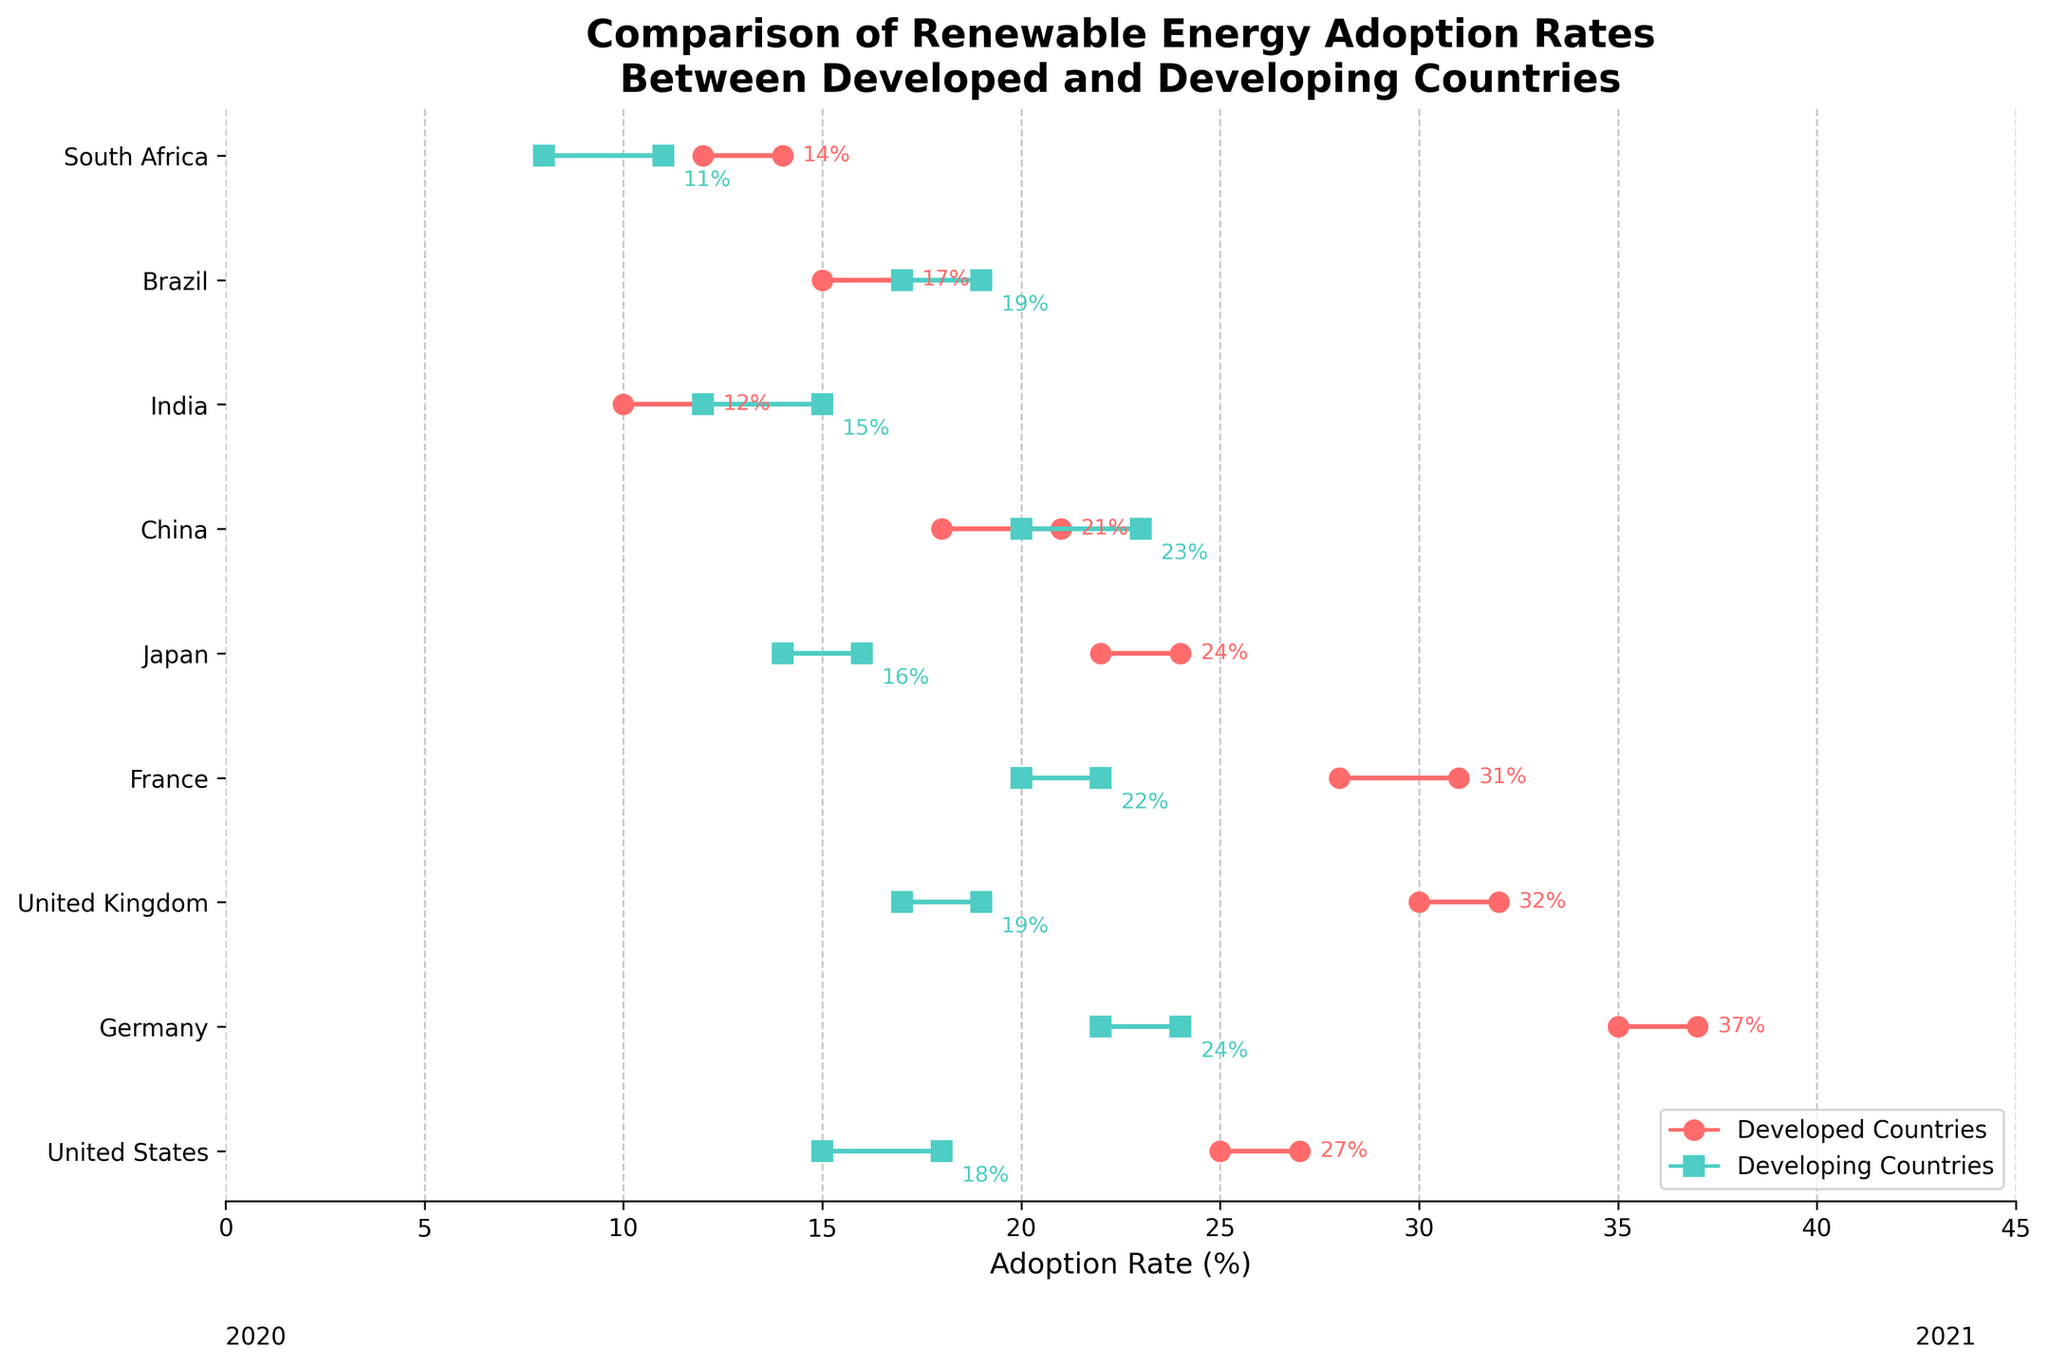What is the adoption rate for developed countries in the United States in 2020? Looking at the United States data points on the plot, the adoption rate for developed countries in 2020 is shown as 25%.
Answer: 25% What is the difference in the adoption rates of developed and developing countries in Germany in 2021? For Germany in 2021, the adoption rates are 37% for developed countries and 24% for developing countries. The difference is 37% - 24% = 13%.
Answer: 13% Which country has the highest adoption rate for developed countries in 2021? Looking at the most rightward point of all red markers (developed countries) in 2021, Germany has the highest value at 37%.
Answer: Germany Which developing country has shown the most significant increase in adoption rate from 2020 to 2021? By comparing the movement of the green markers (developing countries) from 2020 to 2021, China has the most significant increase, going from 20% to 23%, a 3% increase.
Answer: China What is the average adoption rate for developed countries in 2020 across all shown countries? Sum the adoption rates for developed countries in 2020: 25 + 35 + 30 + 28 + 22 + 18 + 10 + 15 + 12 = 195. There are 9 countries, so the average is 195 / 9 ≈ 21.67%.
Answer: 21.67% What is the median adoption rate for developing countries in 2020? List the 2020 developing adoption rates in ascending order: 8, 12, 14, 15, 17, 17, 20, 22. The number of data points is odd (9), so the median is the value in the middle: 17%.
Answer: 17% How does Brazil’s adoption rate for developed countries compare between 2020 and 2021? The adoption rate for Brazil in developed countries increased from 15% in 2020 to 17% in 2021, showing a 2% increase.
Answer: Increased by 2% In 2021, which country has the smallest gap between developed and developing adoption rates? Looking at 2021 data, identify the smallest gap by comparing the differences. Brazil has the smallest gap, with developed at 17% and developing at 19%, a difference of 2%.
Answer: Brazil How does France’s adoption rate for developed countries compare to Japan’s in 2021? In 2021, France has an adoption rate of 31% for developed countries, while Japan has an adoption rate of 24%. Thus, France's rate is higher.
Answer: France is higher 